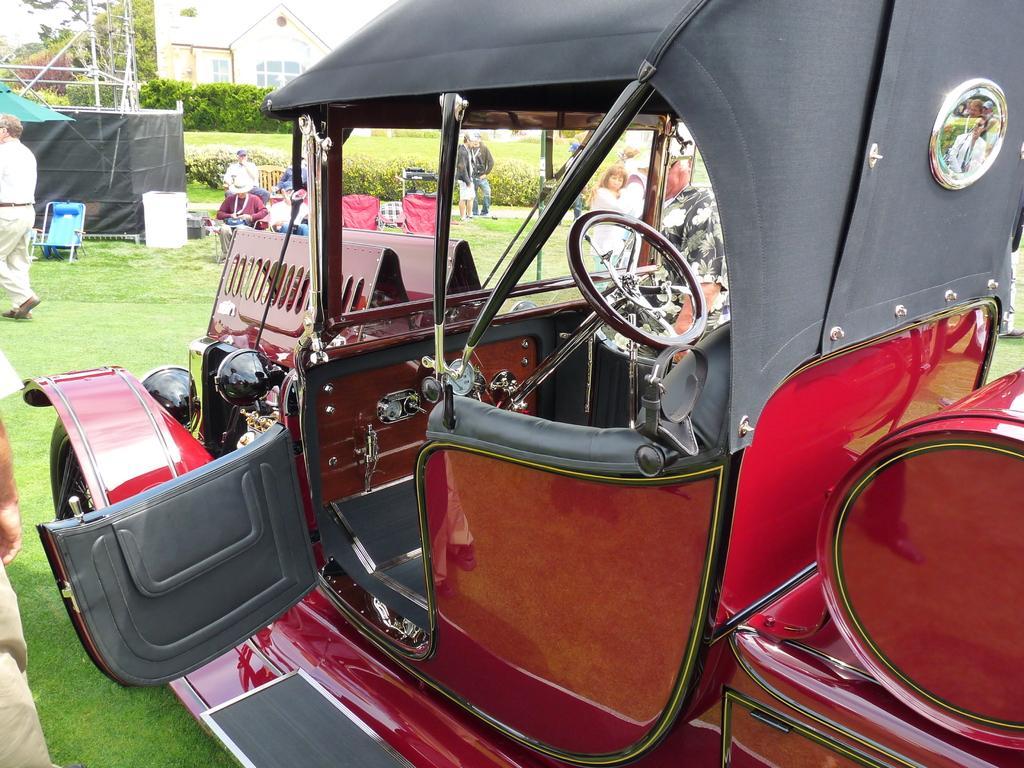Can you describe this image briefly? In this picture I can see a vehicle on the grass, side there are few people and some chairs, background I can see some trees, building. 